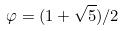Convert formula to latex. <formula><loc_0><loc_0><loc_500><loc_500>\varphi = ( 1 + \sqrt { 5 } ) / 2</formula> 